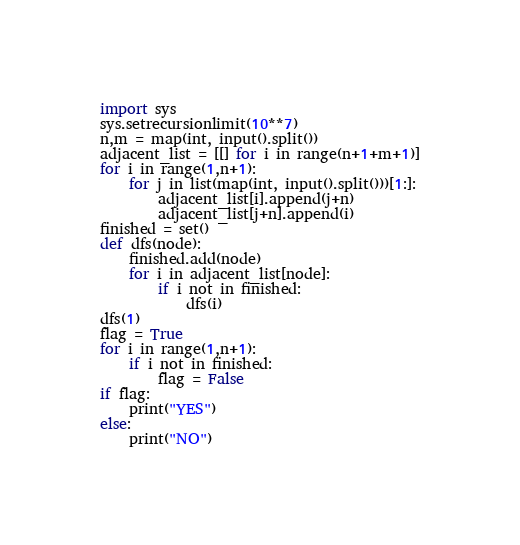<code> <loc_0><loc_0><loc_500><loc_500><_Python_>import sys
sys.setrecursionlimit(10**7)
n,m = map(int, input().split())
adjacent_list = [[] for i in range(n+1+m+1)]
for i in range(1,n+1):
    for j in list(map(int, input().split()))[1:]:
        adjacent_list[i].append(j+n)
        adjacent_list[j+n].append(i)
finished = set()
def dfs(node):
    finished.add(node)
    for i in adjacent_list[node]:
        if i not in finished:
            dfs(i)
dfs(1)
flag = True
for i in range(1,n+1):
    if i not in finished:
        flag = False
if flag:
    print("YES")
else:
    print("NO")</code> 